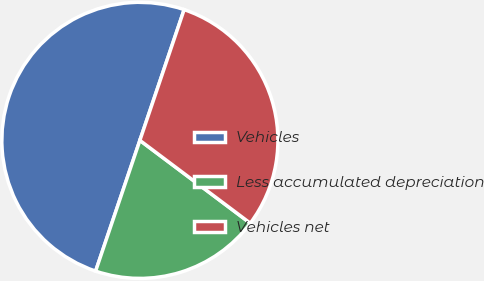<chart> <loc_0><loc_0><loc_500><loc_500><pie_chart><fcel>Vehicles<fcel>Less accumulated depreciation<fcel>Vehicles net<nl><fcel>50.0%<fcel>19.95%<fcel>30.05%<nl></chart> 